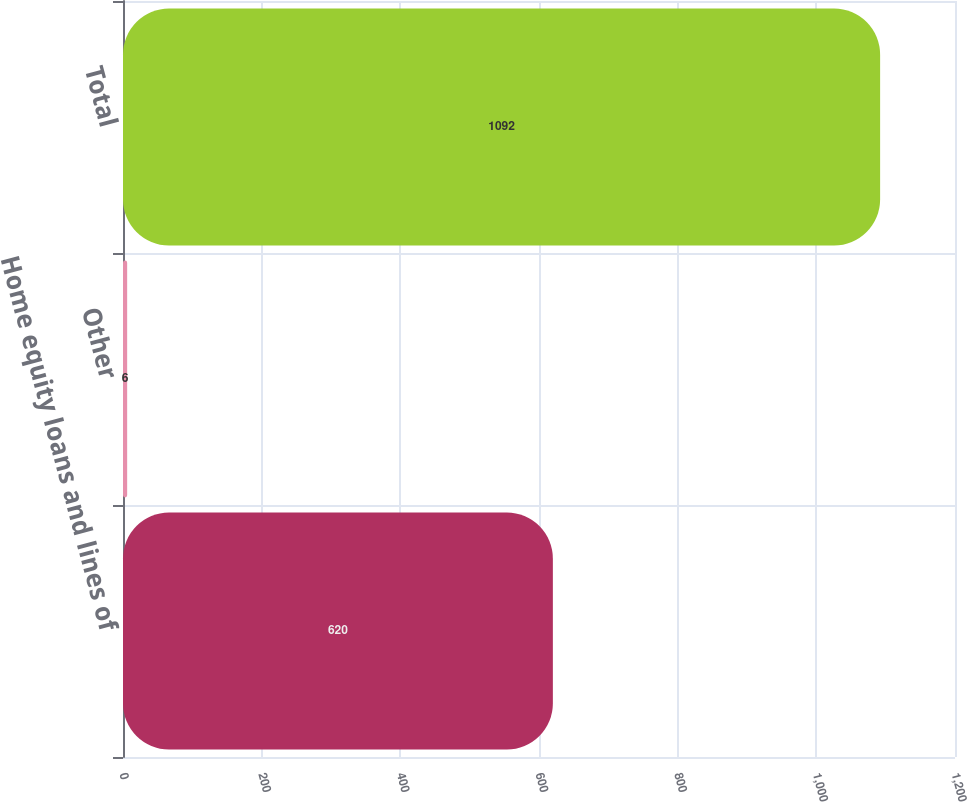Convert chart. <chart><loc_0><loc_0><loc_500><loc_500><bar_chart><fcel>Home equity loans and lines of<fcel>Other<fcel>Total<nl><fcel>620<fcel>6<fcel>1092<nl></chart> 